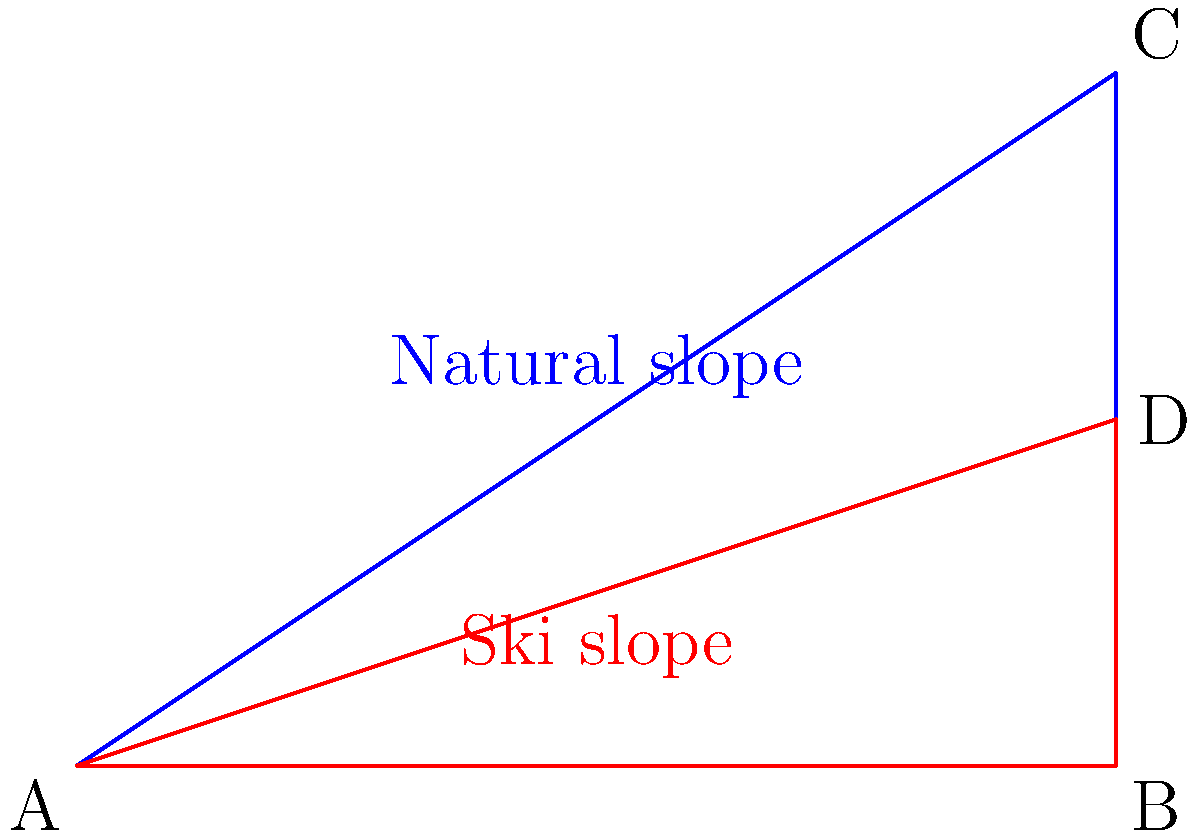A ski resort in the French Alps plans to construct a new ski slope. The natural Alpine slope has an angle of inclination of $\tan^{-1}(\frac{2}{3})$ degrees. The proposed ski slope would have an angle of inclination of 30°. If the horizontal distance of both slopes is 6 km, calculate the difference in vertical height between the natural Alpine slope and the artificial ski slope. How does this alteration impact the authentic Alpine landscape? Let's approach this step-by-step:

1) For the natural Alpine slope (blue triangle ABC):
   - Horizontal distance = 6 km
   - Angle of inclination = $\tan^{-1}(\frac{2}{3})$
   - Vertical height = $6 \tan(\tan^{-1}(\frac{2}{3})) = 6 \cdot \frac{2}{3} = 4$ km

2) For the artificial ski slope (red triangle ABD):
   - Horizontal distance = 6 km
   - Angle of inclination = 30°
   - Vertical height = $6 \tan(30°) = 6 \cdot \frac{1}{\sqrt{3}} \approx 3.464$ km

3) Difference in vertical height:
   $4 - 3.464 = 0.536$ km or approximately 536 meters

This alteration significantly impacts the authentic Alpine landscape. The artificial slope is about 536 meters lower than the natural slope, which:
- Alters the visual aesthetic of the mountain
- May require extensive terraforming, potentially damaging local ecosystems
- Could change local weather patterns and snow accumulation
- Represents a commodification of natural landscapes for tourism
Answer: 536 meters lower; significant landscape alteration 